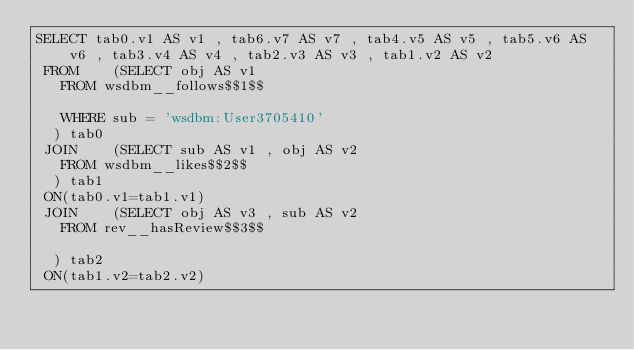Convert code to text. <code><loc_0><loc_0><loc_500><loc_500><_SQL_>SELECT tab0.v1 AS v1 , tab6.v7 AS v7 , tab4.v5 AS v5 , tab5.v6 AS v6 , tab3.v4 AS v4 , tab2.v3 AS v3 , tab1.v2 AS v2 
 FROM    (SELECT obj AS v1 
	 FROM wsdbm__follows$$1$$
	 
	 WHERE sub = 'wsdbm:User3705410'
	) tab0
 JOIN    (SELECT sub AS v1 , obj AS v2 
	 FROM wsdbm__likes$$2$$
	) tab1
 ON(tab0.v1=tab1.v1)
 JOIN    (SELECT obj AS v3 , sub AS v2 
	 FROM rev__hasReview$$3$$
	
	) tab2
 ON(tab1.v2=tab2.v2)</code> 